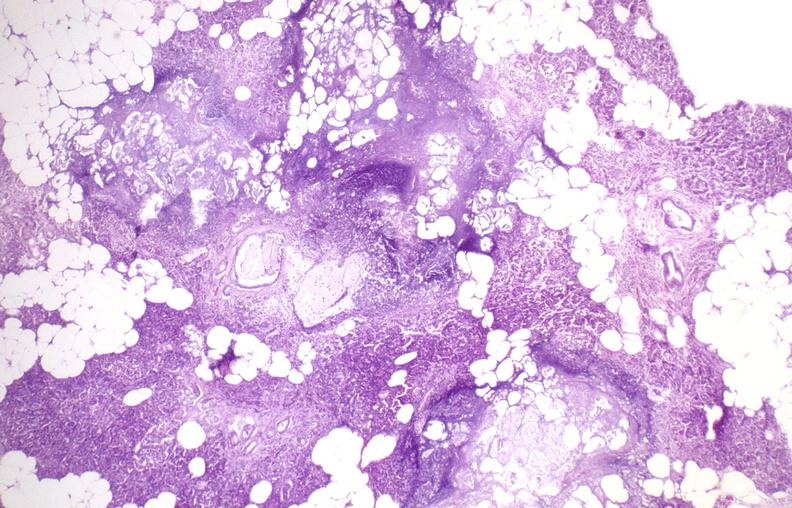what does this image show?
Answer the question using a single word or phrase. Pancreatic fat necrosis 